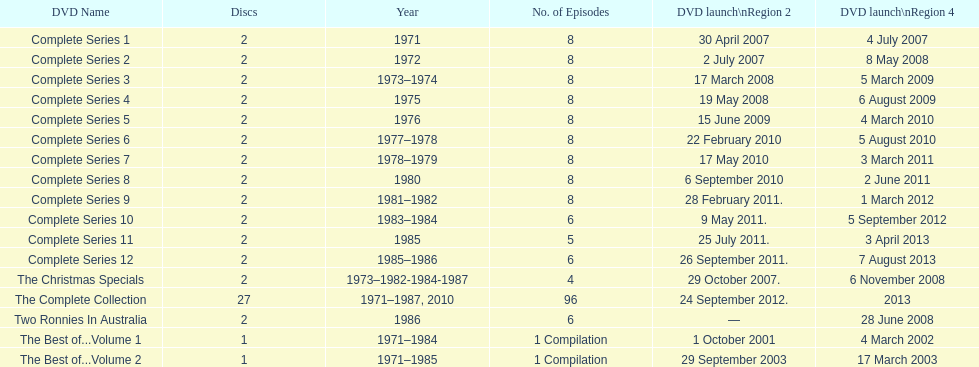The complete collection has 96 episodes, but the christmas specials only has how many episodes? 4. 